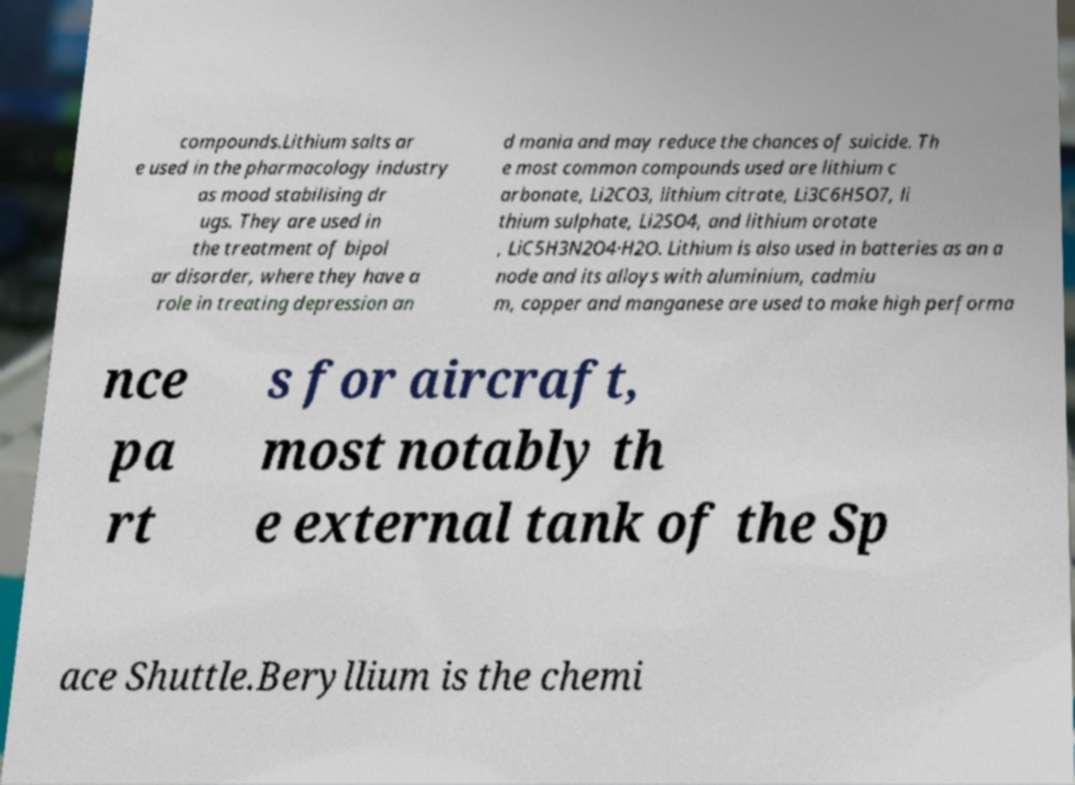Could you assist in decoding the text presented in this image and type it out clearly? compounds.Lithium salts ar e used in the pharmacology industry as mood stabilising dr ugs. They are used in the treatment of bipol ar disorder, where they have a role in treating depression an d mania and may reduce the chances of suicide. Th e most common compounds used are lithium c arbonate, Li2CO3, lithium citrate, Li3C6H5O7, li thium sulphate, Li2SO4, and lithium orotate , LiC5H3N2O4·H2O. Lithium is also used in batteries as an a node and its alloys with aluminium, cadmiu m, copper and manganese are used to make high performa nce pa rt s for aircraft, most notably th e external tank of the Sp ace Shuttle.Beryllium is the chemi 